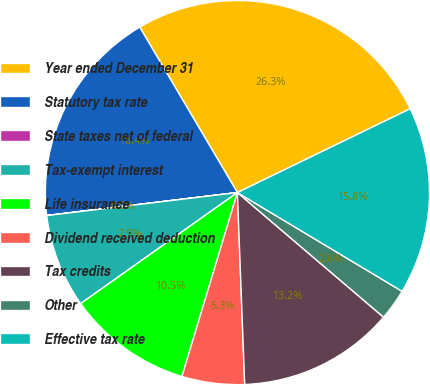<chart> <loc_0><loc_0><loc_500><loc_500><pie_chart><fcel>Year ended December 31<fcel>Statutory tax rate<fcel>State taxes net of federal<fcel>Tax-exempt interest<fcel>Life insurance<fcel>Dividend received deduction<fcel>Tax credits<fcel>Other<fcel>Effective tax rate<nl><fcel>26.31%<fcel>18.42%<fcel>0.01%<fcel>7.9%<fcel>10.53%<fcel>5.27%<fcel>13.16%<fcel>2.64%<fcel>15.79%<nl></chart> 